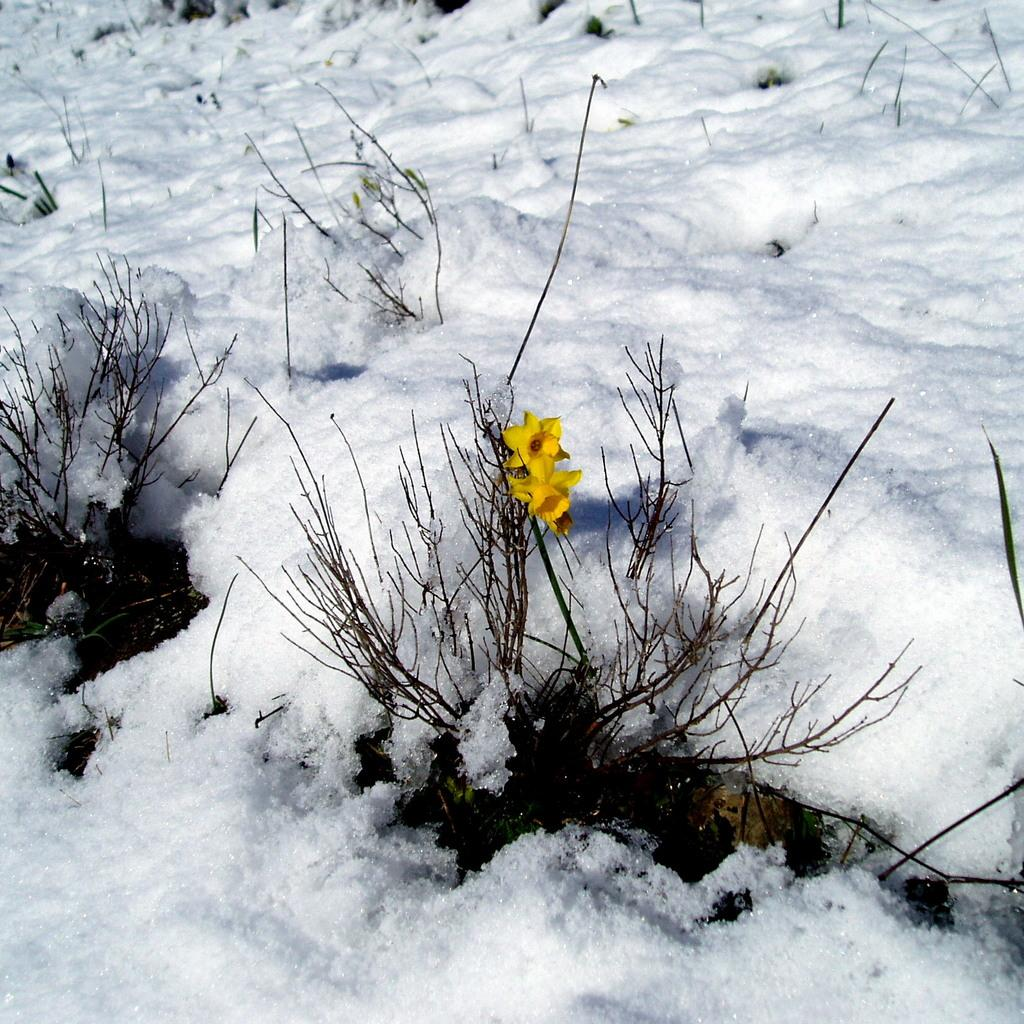What type of flora can be seen in the image? There are flowers and plants in the image. What color are the flowers in the image? The flowers are yellow in color. What type of weather condition is depicted in the image? Snow is visible in the image. What color is the snow in the image? The snow is white in color. What type of account is being discussed in the image? There is no account being discussed in the image; it features flowers, plants, and snow. What type of skirt is visible on the flowers in the image? There are no skirts present in the image; it features flowers, plants, and snow. 